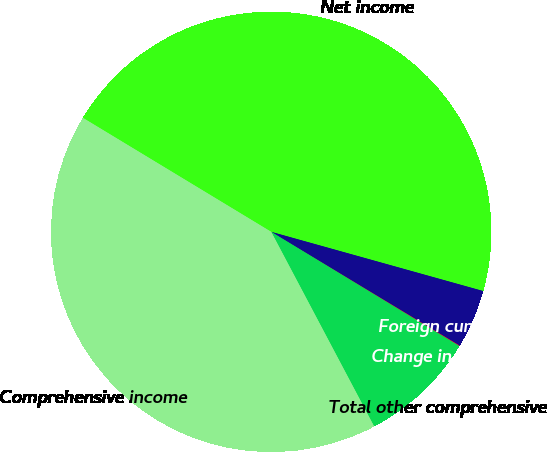Convert chart. <chart><loc_0><loc_0><loc_500><loc_500><pie_chart><fcel>Net income<fcel>Foreign currency translation<fcel>Change in unrealized gains<fcel>Total other comprehensive<fcel>Comprehensive income<nl><fcel>45.67%<fcel>4.31%<fcel>0.04%<fcel>8.57%<fcel>41.41%<nl></chart> 